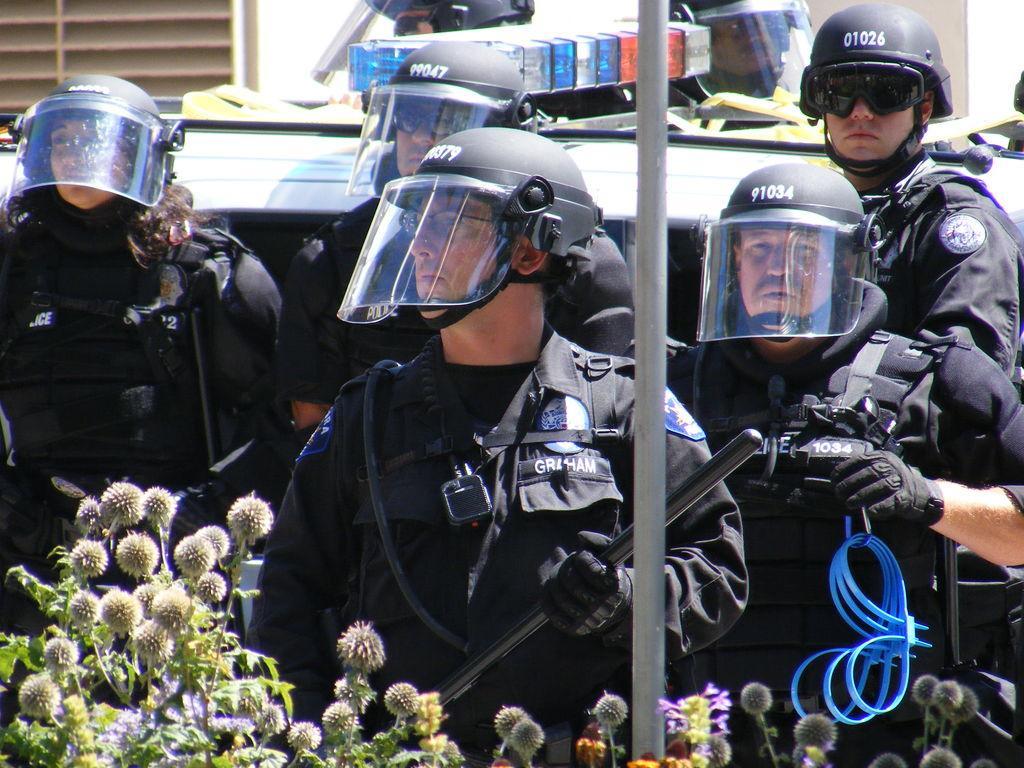Can you describe this image briefly? There is a group of cops wearing black uniform and standing behind a pole, behind the cops there is a vehicle and in the front there are some unwanted plants. 